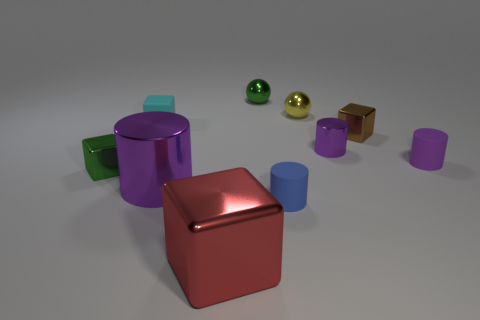What material is the blue thing that is the same size as the yellow metallic sphere?
Your answer should be compact. Rubber. There is a small shiny cylinder on the left side of the purple rubber thing; is there a large purple metal cylinder that is to the right of it?
Provide a succinct answer. No. What number of other objects are there of the same color as the large cylinder?
Your response must be concise. 2. What size is the red cube?
Your answer should be very brief. Large. Is there a brown metallic thing?
Keep it short and to the point. Yes. Are there more large metallic cylinders that are in front of the green metal ball than big metallic blocks that are behind the red thing?
Give a very brief answer. Yes. The object that is in front of the purple rubber cylinder and right of the green shiny sphere is made of what material?
Provide a succinct answer. Rubber. Is the shape of the blue matte thing the same as the large purple shiny object?
Provide a short and direct response. Yes. There is a large red shiny object; what number of big metallic cylinders are behind it?
Give a very brief answer. 1. There is a metallic cylinder on the right side of the blue thing; does it have the same size as the red metal cube?
Provide a succinct answer. No. 